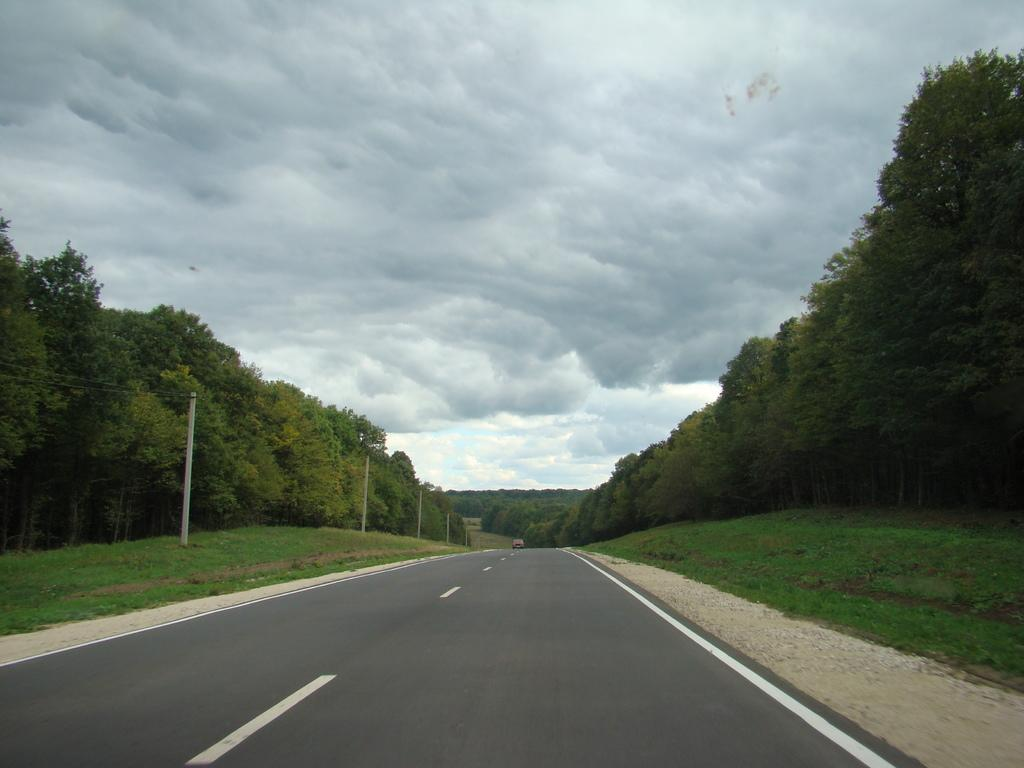What is the main feature of the image? There is a road in the image. What can be seen on the road? The road has white lines on it. What is visible in the background of the image? Poles with wires attached to them, grass, trees, and the sky are visible in the background. What type of creature can be seen playing with friends in space in the image? There is no creature or friends in space present in the image; it features a road with white lines and a background containing poles with wires, grass, trees, and the sky. 